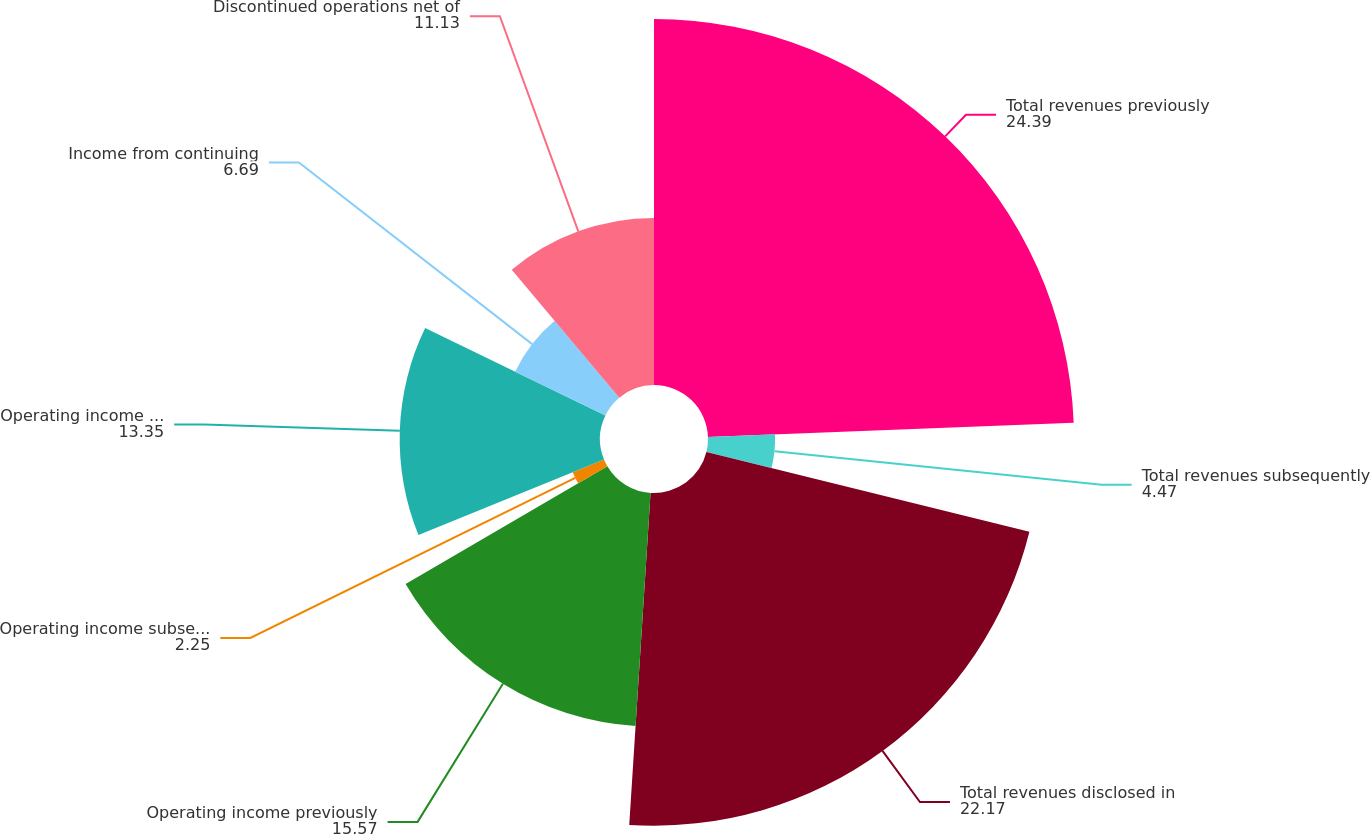Convert chart. <chart><loc_0><loc_0><loc_500><loc_500><pie_chart><fcel>Total revenues previously<fcel>Total revenues subsequently<fcel>Total revenues disclosed in<fcel>Operating income previously<fcel>Operating income subsequently<fcel>Operating income disclosed in<fcel>Income from continuing<fcel>Discontinued operations net of<nl><fcel>24.39%<fcel>4.47%<fcel>22.17%<fcel>15.57%<fcel>2.25%<fcel>13.35%<fcel>6.69%<fcel>11.13%<nl></chart> 